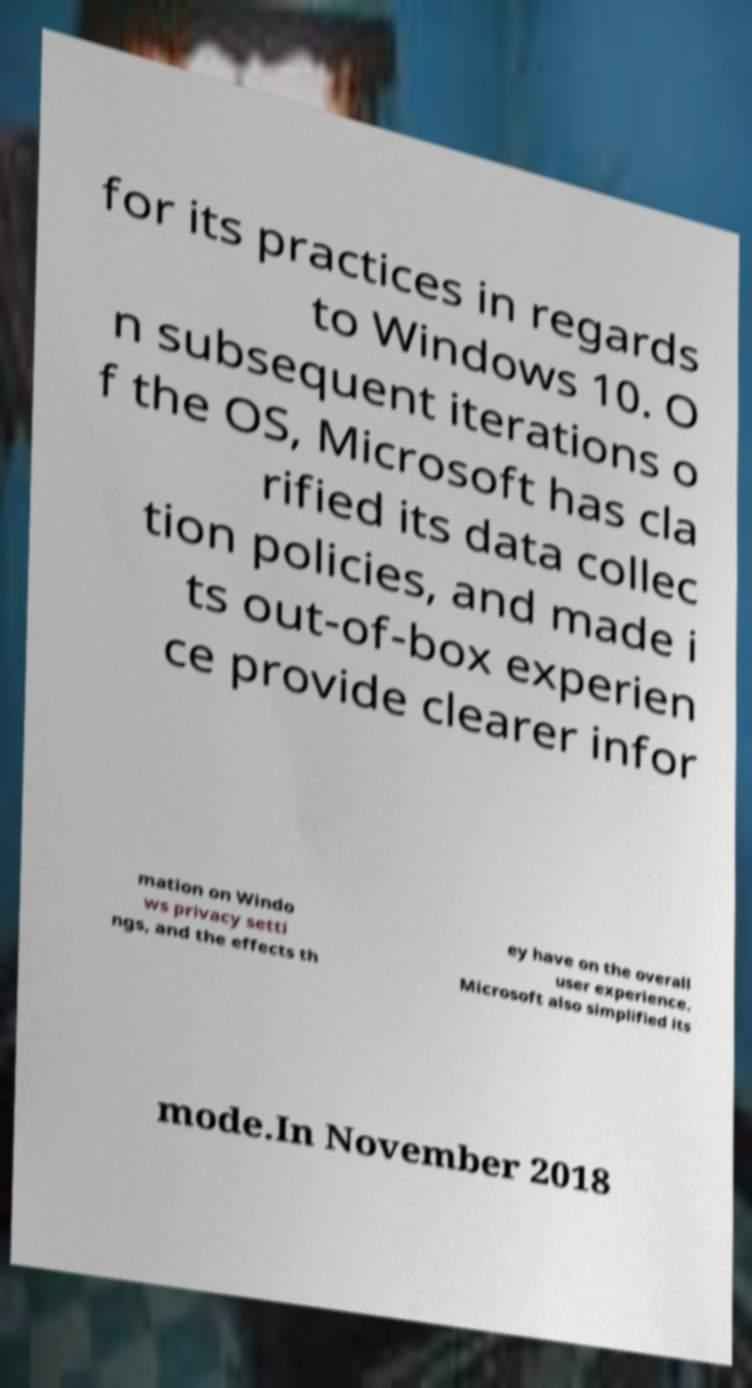There's text embedded in this image that I need extracted. Can you transcribe it verbatim? for its practices in regards to Windows 10. O n subsequent iterations o f the OS, Microsoft has cla rified its data collec tion policies, and made i ts out-of-box experien ce provide clearer infor mation on Windo ws privacy setti ngs, and the effects th ey have on the overall user experience. Microsoft also simplified its mode.In November 2018 